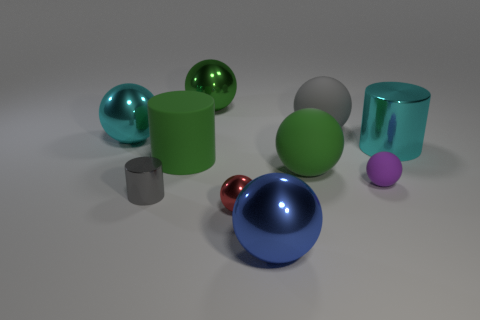Subtract all small spheres. How many spheres are left? 5 Subtract 1 balls. How many balls are left? 6 Subtract all red spheres. How many spheres are left? 6 Subtract all blue balls. Subtract all brown cylinders. How many balls are left? 6 Subtract all spheres. How many objects are left? 3 Add 8 tiny cylinders. How many tiny cylinders are left? 9 Add 7 large brown metallic cylinders. How many large brown metallic cylinders exist? 7 Subtract 1 gray spheres. How many objects are left? 9 Subtract all large green metal balls. Subtract all big gray matte objects. How many objects are left? 8 